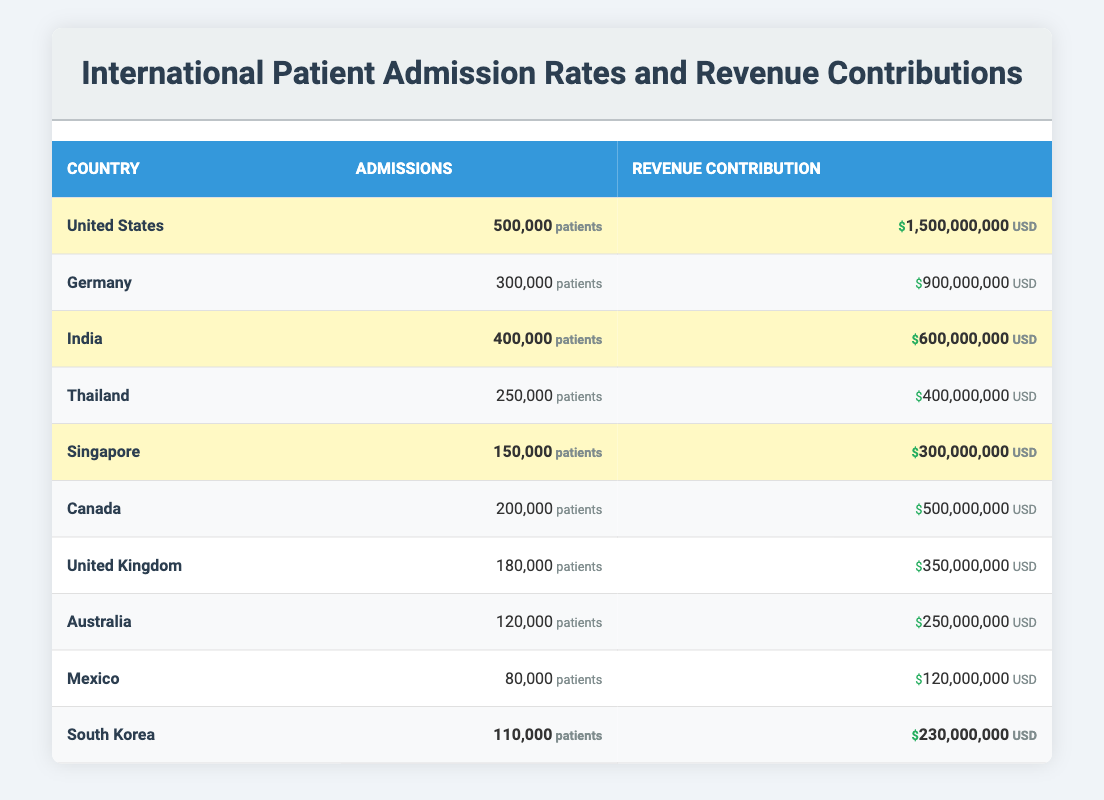What country has the highest number of international patient admissions? By examining the table, we can see that the United States has 500,000 admissions, which is the highest compared to all other countries listed.
Answer: United States What is the revenue contribution from Germany? Looking at the table, Germany's revenue contribution is listed as 900,000,000 USD.
Answer: 900,000,000 USD Which country among the highlighted ones has the lowest admission rate? From the highlighted entries, we observe that Singapore has 150,000 admissions, which is lower than the other highlighted countries (United States with 500,000, India with 400,000, and South Korea with 110,000).
Answer: Singapore What is the total admission rate for highlighted countries? Adding the admissions from the highlighted countries: United States (500,000) + India (400,000) + Singapore (150,000) + South Korea (110,000) = 1,160,000.
Answer: 1,160,000 Is the revenue contribution from South Korea greater than that of Canada? The table shows South Korea's revenue contribution as 230,000,000 USD and Canada's as 500,000,000 USD. Since 230,000,000 is less than 500,000,000, the statement is false.
Answer: No Which country contributes the most to revenue among the highlighted countries? The highlighted countries have the following revenue contributions: United States (1,500,000,000), India (600,000,000), Singapore (300,000,000), and South Korea (230,000,000). The highest among these is from the United States, which contributes 1,500,000,000 USD.
Answer: United States What is the average revenue contribution of all countries listed? To find the average revenue, we sum the contributions: (1,500,000,000 + 900,000,000 + 600,000,000 + 400,000,000 + 300,000,000 + 500,000,000 + 350,000,000 + 250,000,000 + 120,000,000) = 5,020,000,000. There are 10 countries, so the average is 5,020,000,000 / 10 = 502,000,000.
Answer: 502,000,000 How many admissions do the top three countries collectively account for? The top three countries based on admissions are the United States (500,000), India (400,000), and Germany (300,000). Adding these gives: 500,000 + 400,000 + 300,000 = 1,200,000.
Answer: 1,200,000 Does Canada have a higher or lower admission rate than Australia? The table shows that Canada has 200,000 admissions while Australia has 120,000 admissions. Since 200,000 is greater than 120,000, the statement is true.
Answer: Higher What percentage of the total admissions come from the United States? First, we total the admissions from all countries: 500,000 + 300,000 + 400,000 + 250,000 + 150,000 + 200,000 + 180,000 + 120,000 + 80,000 + 110,000 = 2,490,000. The percentage from the United States is (500,000 / 2,490,000) * 100 ≈ 20.08%.
Answer: 20.08% 